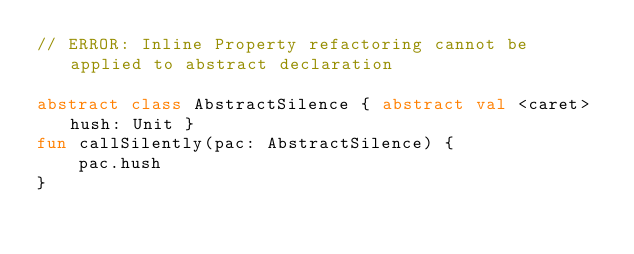Convert code to text. <code><loc_0><loc_0><loc_500><loc_500><_Kotlin_>// ERROR: Inline Property refactoring cannot be applied to abstract declaration

abstract class AbstractSilence { abstract val <caret>hush: Unit }
fun callSilently(pac: AbstractSilence) {
    pac.hush
}</code> 